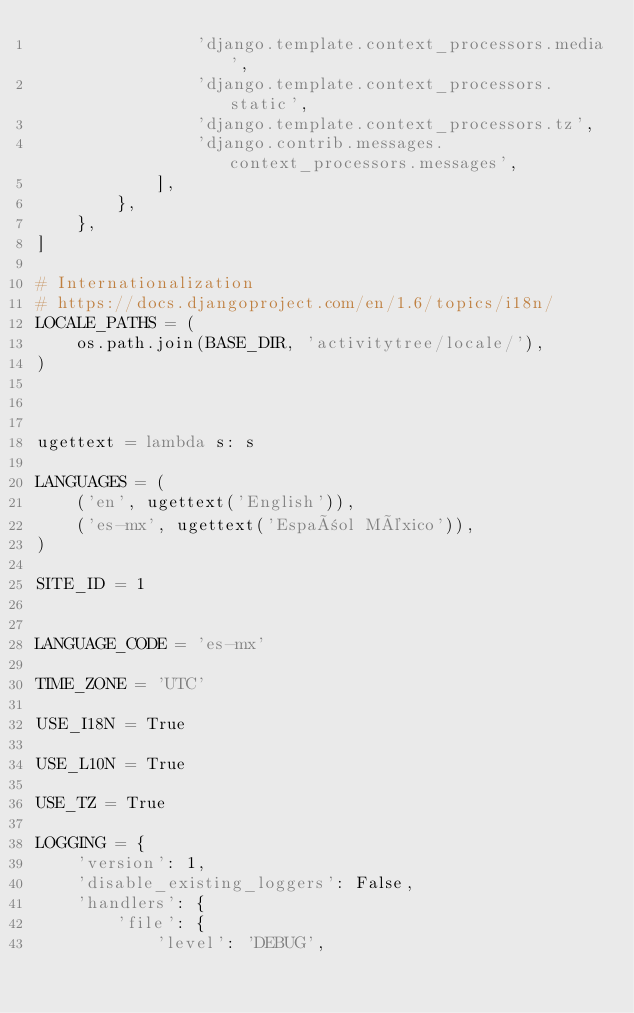<code> <loc_0><loc_0><loc_500><loc_500><_Python_>                'django.template.context_processors.media',
                'django.template.context_processors.static',
                'django.template.context_processors.tz',
                'django.contrib.messages.context_processors.messages',
            ],
        },
    },
]

# Internationalization
# https://docs.djangoproject.com/en/1.6/topics/i18n/
LOCALE_PATHS = (
    os.path.join(BASE_DIR, 'activitytree/locale/'),
)



ugettext = lambda s: s

LANGUAGES = (
    ('en', ugettext('English')),
    ('es-mx', ugettext('Español México')),
)

SITE_ID = 1


LANGUAGE_CODE = 'es-mx'

TIME_ZONE = 'UTC'

USE_I18N = True

USE_L10N = True

USE_TZ = True

LOGGING = {
    'version': 1,
    'disable_existing_loggers': False,
    'handlers': {
        'file': {
            'level': 'DEBUG',</code> 